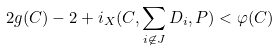Convert formula to latex. <formula><loc_0><loc_0><loc_500><loc_500>2 g ( C ) - 2 + i _ { X } ( C , \sum _ { i \not \in J } D _ { i } , P ) < \varphi ( C )</formula> 